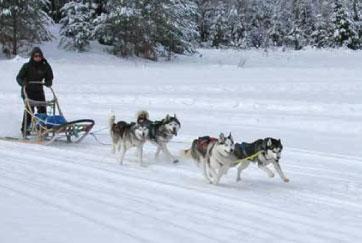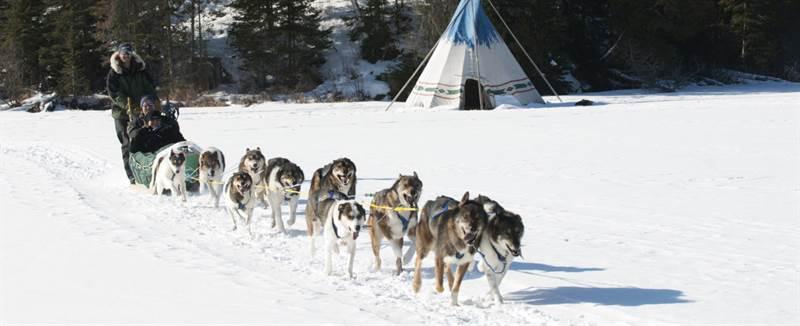The first image is the image on the left, the second image is the image on the right. Assess this claim about the two images: "The right image shows a dog team moving rightward across the snow past a type of housing shelter on the right.". Correct or not? Answer yes or no. Yes. 